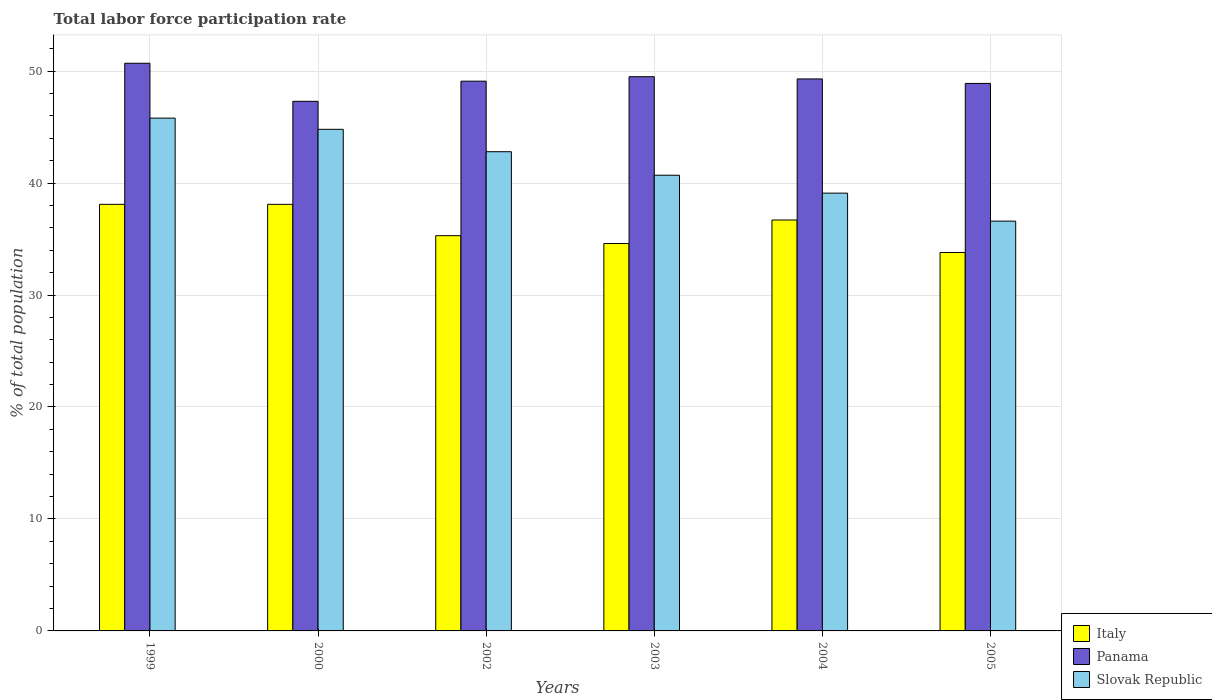How many different coloured bars are there?
Provide a succinct answer. 3. How many groups of bars are there?
Your answer should be very brief. 6. How many bars are there on the 5th tick from the left?
Your answer should be compact. 3. What is the label of the 3rd group of bars from the left?
Provide a succinct answer. 2002. What is the total labor force participation rate in Italy in 1999?
Provide a short and direct response. 38.1. Across all years, what is the maximum total labor force participation rate in Panama?
Keep it short and to the point. 50.7. Across all years, what is the minimum total labor force participation rate in Italy?
Give a very brief answer. 33.8. What is the total total labor force participation rate in Slovak Republic in the graph?
Ensure brevity in your answer.  249.8. What is the difference between the total labor force participation rate in Panama in 1999 and that in 2000?
Your response must be concise. 3.4. What is the difference between the total labor force participation rate in Panama in 2005 and the total labor force participation rate in Slovak Republic in 2004?
Provide a short and direct response. 9.8. What is the average total labor force participation rate in Slovak Republic per year?
Make the answer very short. 41.63. In the year 2002, what is the difference between the total labor force participation rate in Panama and total labor force participation rate in Slovak Republic?
Make the answer very short. 6.3. What is the ratio of the total labor force participation rate in Panama in 1999 to that in 2002?
Provide a short and direct response. 1.03. Is the total labor force participation rate in Slovak Republic in 2000 less than that in 2005?
Your answer should be very brief. No. Is the difference between the total labor force participation rate in Panama in 1999 and 2004 greater than the difference between the total labor force participation rate in Slovak Republic in 1999 and 2004?
Offer a very short reply. No. What is the difference between the highest and the lowest total labor force participation rate in Italy?
Ensure brevity in your answer.  4.3. In how many years, is the total labor force participation rate in Panama greater than the average total labor force participation rate in Panama taken over all years?
Give a very brief answer. 3. What does the 3rd bar from the left in 1999 represents?
Your response must be concise. Slovak Republic. What does the 3rd bar from the right in 2003 represents?
Your answer should be very brief. Italy. How many years are there in the graph?
Provide a short and direct response. 6. What is the difference between two consecutive major ticks on the Y-axis?
Your response must be concise. 10. Are the values on the major ticks of Y-axis written in scientific E-notation?
Your answer should be very brief. No. Does the graph contain grids?
Give a very brief answer. Yes. What is the title of the graph?
Provide a short and direct response. Total labor force participation rate. What is the label or title of the Y-axis?
Offer a very short reply. % of total population. What is the % of total population of Italy in 1999?
Ensure brevity in your answer.  38.1. What is the % of total population of Panama in 1999?
Your response must be concise. 50.7. What is the % of total population of Slovak Republic in 1999?
Offer a very short reply. 45.8. What is the % of total population of Italy in 2000?
Ensure brevity in your answer.  38.1. What is the % of total population in Panama in 2000?
Make the answer very short. 47.3. What is the % of total population of Slovak Republic in 2000?
Make the answer very short. 44.8. What is the % of total population in Italy in 2002?
Your answer should be compact. 35.3. What is the % of total population in Panama in 2002?
Your answer should be compact. 49.1. What is the % of total population in Slovak Republic in 2002?
Your response must be concise. 42.8. What is the % of total population in Italy in 2003?
Provide a short and direct response. 34.6. What is the % of total population in Panama in 2003?
Your response must be concise. 49.5. What is the % of total population of Slovak Republic in 2003?
Make the answer very short. 40.7. What is the % of total population of Italy in 2004?
Keep it short and to the point. 36.7. What is the % of total population of Panama in 2004?
Make the answer very short. 49.3. What is the % of total population of Slovak Republic in 2004?
Ensure brevity in your answer.  39.1. What is the % of total population of Italy in 2005?
Make the answer very short. 33.8. What is the % of total population of Panama in 2005?
Your answer should be very brief. 48.9. What is the % of total population in Slovak Republic in 2005?
Keep it short and to the point. 36.6. Across all years, what is the maximum % of total population in Italy?
Your response must be concise. 38.1. Across all years, what is the maximum % of total population in Panama?
Your answer should be compact. 50.7. Across all years, what is the maximum % of total population of Slovak Republic?
Your response must be concise. 45.8. Across all years, what is the minimum % of total population of Italy?
Your answer should be compact. 33.8. Across all years, what is the minimum % of total population of Panama?
Ensure brevity in your answer.  47.3. Across all years, what is the minimum % of total population in Slovak Republic?
Provide a succinct answer. 36.6. What is the total % of total population in Italy in the graph?
Your answer should be compact. 216.6. What is the total % of total population of Panama in the graph?
Your answer should be compact. 294.8. What is the total % of total population in Slovak Republic in the graph?
Provide a short and direct response. 249.8. What is the difference between the % of total population of Slovak Republic in 1999 and that in 2000?
Make the answer very short. 1. What is the difference between the % of total population in Italy in 1999 and that in 2002?
Make the answer very short. 2.8. What is the difference between the % of total population of Slovak Republic in 1999 and that in 2002?
Keep it short and to the point. 3. What is the difference between the % of total population in Italy in 1999 and that in 2003?
Make the answer very short. 3.5. What is the difference between the % of total population of Slovak Republic in 1999 and that in 2003?
Give a very brief answer. 5.1. What is the difference between the % of total population of Slovak Republic in 1999 and that in 2004?
Provide a short and direct response. 6.7. What is the difference between the % of total population in Panama in 1999 and that in 2005?
Keep it short and to the point. 1.8. What is the difference between the % of total population of Italy in 2000 and that in 2002?
Make the answer very short. 2.8. What is the difference between the % of total population in Italy in 2000 and that in 2003?
Your answer should be compact. 3.5. What is the difference between the % of total population of Italy in 2000 and that in 2004?
Make the answer very short. 1.4. What is the difference between the % of total population of Panama in 2000 and that in 2004?
Your response must be concise. -2. What is the difference between the % of total population of Slovak Republic in 2000 and that in 2004?
Your response must be concise. 5.7. What is the difference between the % of total population in Italy in 2000 and that in 2005?
Offer a terse response. 4.3. What is the difference between the % of total population in Italy in 2002 and that in 2003?
Give a very brief answer. 0.7. What is the difference between the % of total population in Slovak Republic in 2002 and that in 2003?
Make the answer very short. 2.1. What is the difference between the % of total population of Italy in 2002 and that in 2004?
Offer a very short reply. -1.4. What is the difference between the % of total population in Slovak Republic in 2003 and that in 2005?
Your response must be concise. 4.1. What is the difference between the % of total population in Panama in 2004 and that in 2005?
Keep it short and to the point. 0.4. What is the difference between the % of total population in Slovak Republic in 2004 and that in 2005?
Ensure brevity in your answer.  2.5. What is the difference between the % of total population in Panama in 1999 and the % of total population in Slovak Republic in 2000?
Give a very brief answer. 5.9. What is the difference between the % of total population of Italy in 1999 and the % of total population of Slovak Republic in 2002?
Your answer should be compact. -4.7. What is the difference between the % of total population of Italy in 1999 and the % of total population of Panama in 2003?
Your answer should be compact. -11.4. What is the difference between the % of total population in Italy in 1999 and the % of total population in Panama in 2004?
Provide a short and direct response. -11.2. What is the difference between the % of total population of Italy in 1999 and the % of total population of Slovak Republic in 2004?
Your response must be concise. -1. What is the difference between the % of total population in Panama in 1999 and the % of total population in Slovak Republic in 2004?
Ensure brevity in your answer.  11.6. What is the difference between the % of total population of Italy in 1999 and the % of total population of Panama in 2005?
Offer a very short reply. -10.8. What is the difference between the % of total population in Panama in 1999 and the % of total population in Slovak Republic in 2005?
Provide a succinct answer. 14.1. What is the difference between the % of total population in Italy in 2000 and the % of total population in Panama in 2002?
Offer a very short reply. -11. What is the difference between the % of total population in Italy in 2000 and the % of total population in Panama in 2003?
Make the answer very short. -11.4. What is the difference between the % of total population of Italy in 2000 and the % of total population of Slovak Republic in 2004?
Ensure brevity in your answer.  -1. What is the difference between the % of total population in Italy in 2000 and the % of total population in Panama in 2005?
Make the answer very short. -10.8. What is the difference between the % of total population in Italy in 2002 and the % of total population in Slovak Republic in 2003?
Give a very brief answer. -5.4. What is the difference between the % of total population of Panama in 2002 and the % of total population of Slovak Republic in 2003?
Make the answer very short. 8.4. What is the difference between the % of total population of Italy in 2002 and the % of total population of Panama in 2005?
Your answer should be compact. -13.6. What is the difference between the % of total population in Italy in 2003 and the % of total population in Panama in 2004?
Keep it short and to the point. -14.7. What is the difference between the % of total population of Panama in 2003 and the % of total population of Slovak Republic in 2004?
Keep it short and to the point. 10.4. What is the difference between the % of total population in Italy in 2003 and the % of total population in Panama in 2005?
Provide a short and direct response. -14.3. What is the difference between the % of total population in Italy in 2003 and the % of total population in Slovak Republic in 2005?
Your response must be concise. -2. What is the difference between the % of total population in Panama in 2003 and the % of total population in Slovak Republic in 2005?
Your answer should be very brief. 12.9. What is the difference between the % of total population of Panama in 2004 and the % of total population of Slovak Republic in 2005?
Provide a succinct answer. 12.7. What is the average % of total population in Italy per year?
Keep it short and to the point. 36.1. What is the average % of total population of Panama per year?
Ensure brevity in your answer.  49.13. What is the average % of total population in Slovak Republic per year?
Make the answer very short. 41.63. In the year 1999, what is the difference between the % of total population of Italy and % of total population of Panama?
Your response must be concise. -12.6. In the year 1999, what is the difference between the % of total population of Italy and % of total population of Slovak Republic?
Ensure brevity in your answer.  -7.7. In the year 2000, what is the difference between the % of total population in Italy and % of total population in Slovak Republic?
Ensure brevity in your answer.  -6.7. In the year 2002, what is the difference between the % of total population in Italy and % of total population in Panama?
Offer a terse response. -13.8. In the year 2002, what is the difference between the % of total population of Panama and % of total population of Slovak Republic?
Offer a terse response. 6.3. In the year 2003, what is the difference between the % of total population of Italy and % of total population of Panama?
Offer a very short reply. -14.9. In the year 2004, what is the difference between the % of total population in Italy and % of total population in Panama?
Make the answer very short. -12.6. In the year 2004, what is the difference between the % of total population in Italy and % of total population in Slovak Republic?
Keep it short and to the point. -2.4. In the year 2005, what is the difference between the % of total population of Italy and % of total population of Panama?
Offer a terse response. -15.1. In the year 2005, what is the difference between the % of total population in Italy and % of total population in Slovak Republic?
Make the answer very short. -2.8. What is the ratio of the % of total population in Panama in 1999 to that in 2000?
Your answer should be compact. 1.07. What is the ratio of the % of total population in Slovak Republic in 1999 to that in 2000?
Keep it short and to the point. 1.02. What is the ratio of the % of total population of Italy in 1999 to that in 2002?
Your answer should be compact. 1.08. What is the ratio of the % of total population of Panama in 1999 to that in 2002?
Keep it short and to the point. 1.03. What is the ratio of the % of total population of Slovak Republic in 1999 to that in 2002?
Provide a short and direct response. 1.07. What is the ratio of the % of total population of Italy in 1999 to that in 2003?
Keep it short and to the point. 1.1. What is the ratio of the % of total population in Panama in 1999 to that in 2003?
Provide a succinct answer. 1.02. What is the ratio of the % of total population of Slovak Republic in 1999 to that in 2003?
Ensure brevity in your answer.  1.13. What is the ratio of the % of total population of Italy in 1999 to that in 2004?
Your answer should be very brief. 1.04. What is the ratio of the % of total population of Panama in 1999 to that in 2004?
Make the answer very short. 1.03. What is the ratio of the % of total population in Slovak Republic in 1999 to that in 2004?
Provide a short and direct response. 1.17. What is the ratio of the % of total population of Italy in 1999 to that in 2005?
Offer a very short reply. 1.13. What is the ratio of the % of total population in Panama in 1999 to that in 2005?
Your answer should be compact. 1.04. What is the ratio of the % of total population in Slovak Republic in 1999 to that in 2005?
Ensure brevity in your answer.  1.25. What is the ratio of the % of total population in Italy in 2000 to that in 2002?
Keep it short and to the point. 1.08. What is the ratio of the % of total population of Panama in 2000 to that in 2002?
Offer a terse response. 0.96. What is the ratio of the % of total population in Slovak Republic in 2000 to that in 2002?
Give a very brief answer. 1.05. What is the ratio of the % of total population of Italy in 2000 to that in 2003?
Offer a very short reply. 1.1. What is the ratio of the % of total population of Panama in 2000 to that in 2003?
Keep it short and to the point. 0.96. What is the ratio of the % of total population of Slovak Republic in 2000 to that in 2003?
Provide a succinct answer. 1.1. What is the ratio of the % of total population of Italy in 2000 to that in 2004?
Make the answer very short. 1.04. What is the ratio of the % of total population of Panama in 2000 to that in 2004?
Ensure brevity in your answer.  0.96. What is the ratio of the % of total population of Slovak Republic in 2000 to that in 2004?
Offer a terse response. 1.15. What is the ratio of the % of total population in Italy in 2000 to that in 2005?
Make the answer very short. 1.13. What is the ratio of the % of total population in Panama in 2000 to that in 2005?
Offer a terse response. 0.97. What is the ratio of the % of total population in Slovak Republic in 2000 to that in 2005?
Your answer should be compact. 1.22. What is the ratio of the % of total population in Italy in 2002 to that in 2003?
Provide a succinct answer. 1.02. What is the ratio of the % of total population in Slovak Republic in 2002 to that in 2003?
Give a very brief answer. 1.05. What is the ratio of the % of total population in Italy in 2002 to that in 2004?
Keep it short and to the point. 0.96. What is the ratio of the % of total population of Panama in 2002 to that in 2004?
Provide a succinct answer. 1. What is the ratio of the % of total population of Slovak Republic in 2002 to that in 2004?
Provide a short and direct response. 1.09. What is the ratio of the % of total population of Italy in 2002 to that in 2005?
Provide a short and direct response. 1.04. What is the ratio of the % of total population of Slovak Republic in 2002 to that in 2005?
Your answer should be compact. 1.17. What is the ratio of the % of total population of Italy in 2003 to that in 2004?
Offer a very short reply. 0.94. What is the ratio of the % of total population of Panama in 2003 to that in 2004?
Offer a terse response. 1. What is the ratio of the % of total population in Slovak Republic in 2003 to that in 2004?
Keep it short and to the point. 1.04. What is the ratio of the % of total population in Italy in 2003 to that in 2005?
Offer a very short reply. 1.02. What is the ratio of the % of total population of Panama in 2003 to that in 2005?
Give a very brief answer. 1.01. What is the ratio of the % of total population in Slovak Republic in 2003 to that in 2005?
Give a very brief answer. 1.11. What is the ratio of the % of total population in Italy in 2004 to that in 2005?
Give a very brief answer. 1.09. What is the ratio of the % of total population in Panama in 2004 to that in 2005?
Provide a short and direct response. 1.01. What is the ratio of the % of total population of Slovak Republic in 2004 to that in 2005?
Provide a short and direct response. 1.07. What is the difference between the highest and the second highest % of total population in Italy?
Ensure brevity in your answer.  0. What is the difference between the highest and the second highest % of total population of Slovak Republic?
Offer a terse response. 1. What is the difference between the highest and the lowest % of total population in Panama?
Your answer should be very brief. 3.4. 